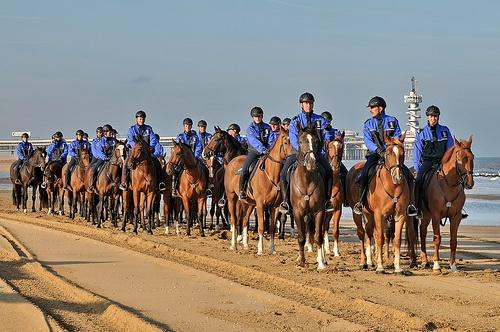Describe the objects in this image and their specific colors. I can see horse in darkgray, black, maroon, tan, and brown tones, horse in darkgray, black, maroon, brown, and tan tones, horse in darkgray, tan, black, brown, and salmon tones, horse in darkgray, black, gray, and maroon tones, and horse in darkgray, black, maroon, brown, and tan tones in this image. 